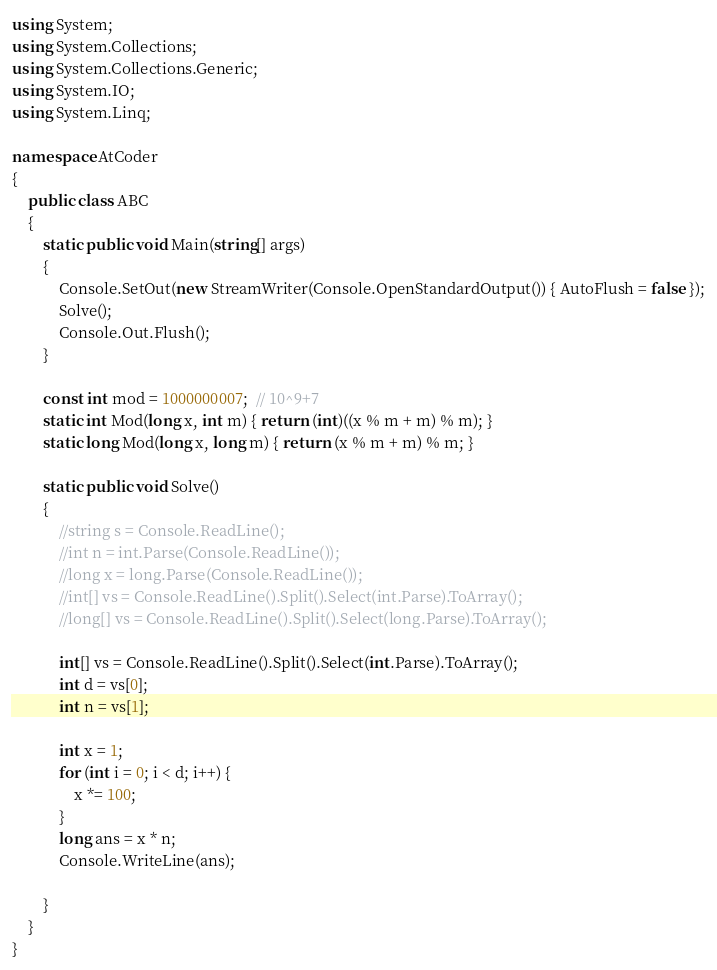<code> <loc_0><loc_0><loc_500><loc_500><_C#_>using System;
using System.Collections;
using System.Collections.Generic;
using System.IO;
using System.Linq;

namespace AtCoder
{
	public class ABC
	{
		static public void Main(string[] args)
		{
			Console.SetOut(new StreamWriter(Console.OpenStandardOutput()) { AutoFlush = false });
			Solve();
			Console.Out.Flush();
		}

		const int mod = 1000000007;  // 10^9+7
		static int Mod(long x, int m) { return (int)((x % m + m) % m); }
		static long Mod(long x, long m) { return (x % m + m) % m; }

		static public void Solve()
		{
			//string s = Console.ReadLine();
			//int n = int.Parse(Console.ReadLine());
			//long x = long.Parse(Console.ReadLine());
			//int[] vs = Console.ReadLine().Split().Select(int.Parse).ToArray();
			//long[] vs = Console.ReadLine().Split().Select(long.Parse).ToArray();

			int[] vs = Console.ReadLine().Split().Select(int.Parse).ToArray();
			int d = vs[0];
			int n = vs[1];

			int x = 1;
			for (int i = 0; i < d; i++) {
				x *= 100;
			}
			long ans = x * n;
			Console.WriteLine(ans);

		}
	}
}
</code> 